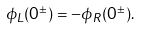<formula> <loc_0><loc_0><loc_500><loc_500>\phi _ { L } ( 0 ^ { \pm } ) = - \phi _ { R } ( 0 ^ { \pm } ) .</formula> 